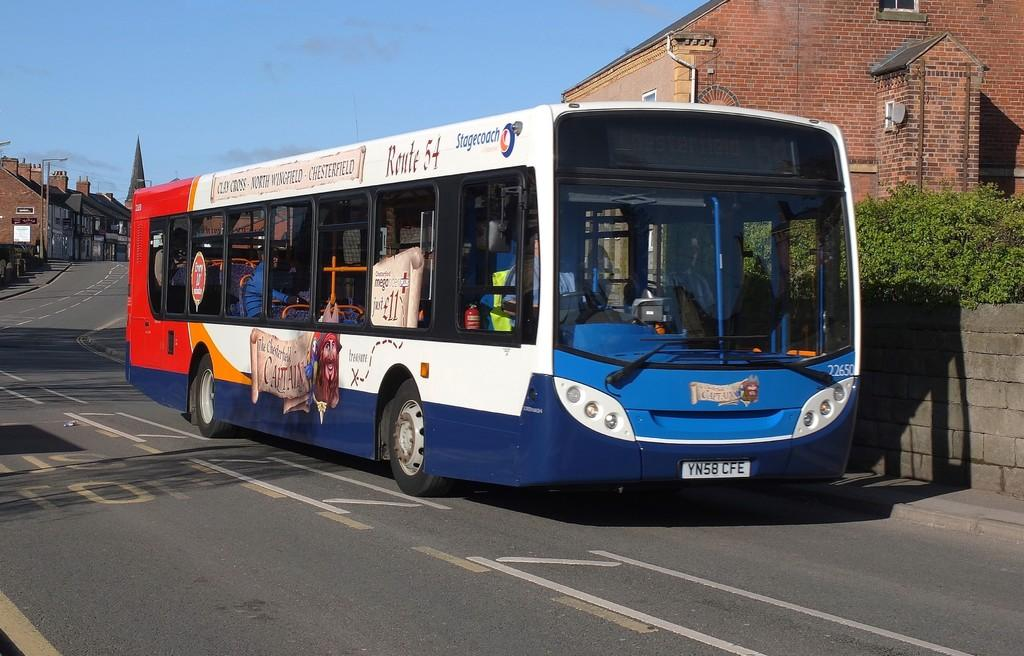<image>
Present a compact description of the photo's key features. A stagecoach bus for route 54 drives on a road. 